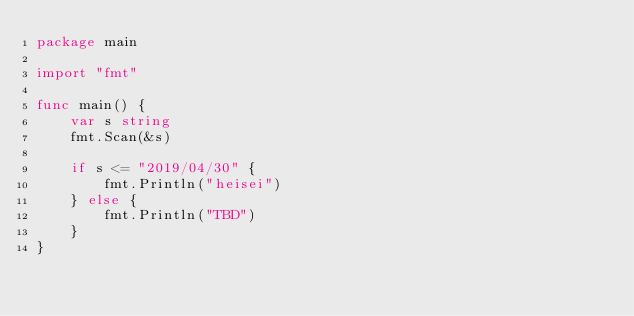<code> <loc_0><loc_0><loc_500><loc_500><_Go_>package main

import "fmt"

func main() {
	var s string
	fmt.Scan(&s)

	if s <= "2019/04/30" {
		fmt.Println("heisei")
	} else {
		fmt.Println("TBD")
	}
}
</code> 